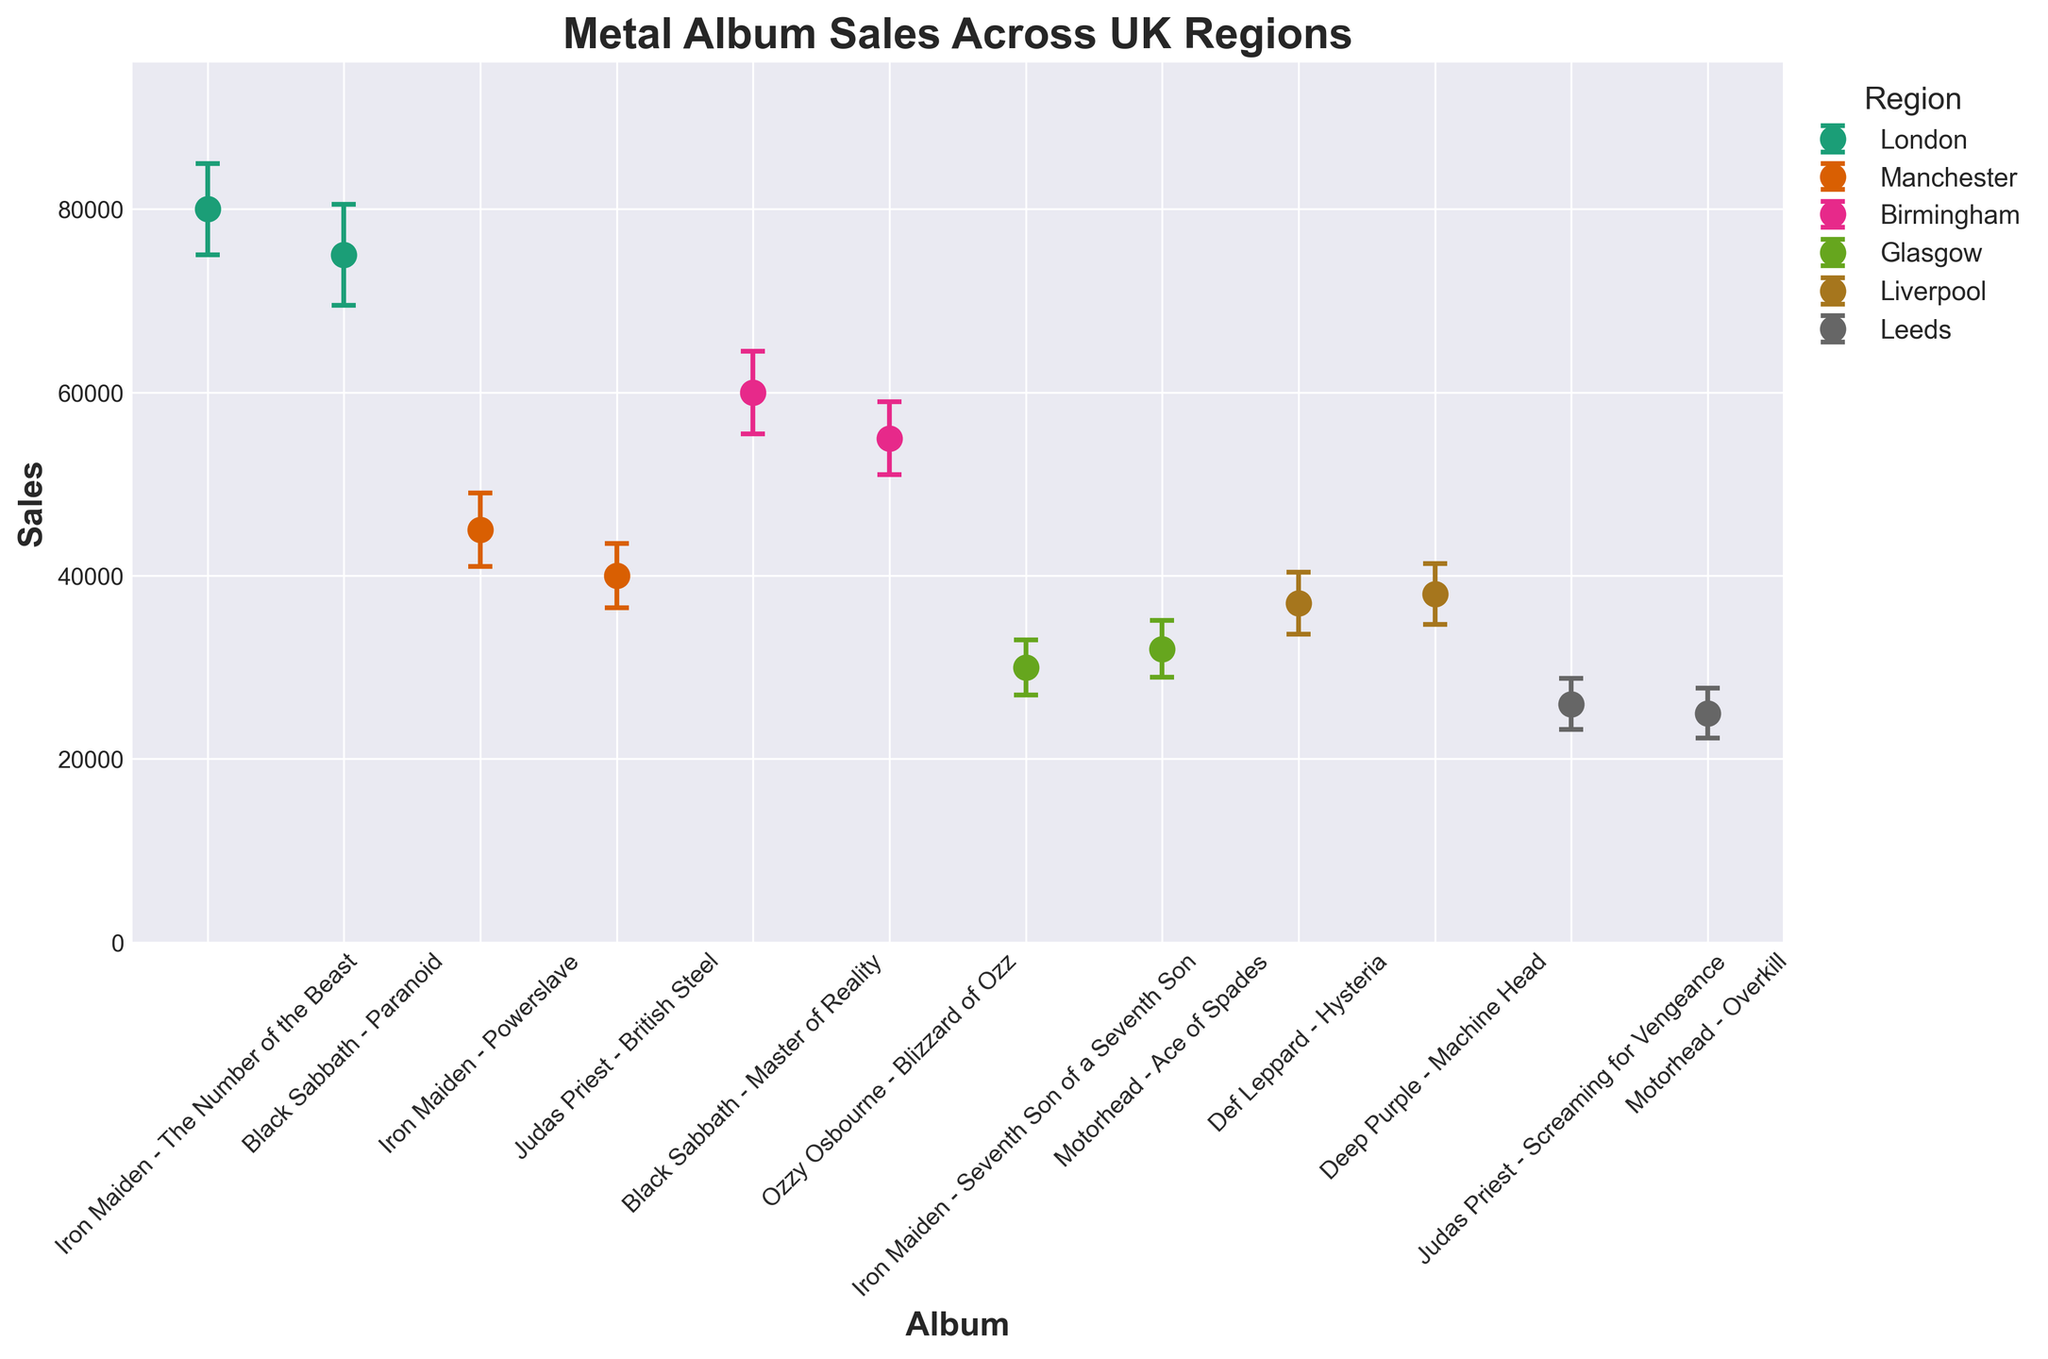What is the title of the figure? The title of the figure is text displayed prominently at the top of the plot. It's "Metal Album Sales Across UK Regions".
Answer: Metal Album Sales Across UK Regions Which region has the highest album sales for "The Number of the Beast"? The album "The Number of the Beast" by Iron Maiden is associated with London. By checking the sales values, London has the highest sales figure at 80,000.
Answer: London How many regions are represented in the plot? The regions are indicated by different colors in the legend on the right-hand side. There are 6 distinct regions: London, Manchester, Birmingham, Glasgow, Liverpool, and Leeds.
Answer: 6 What is the average album sales for Birmingham? Birmingham has two albums: "Master of Reality" with 60,000 sales and "Blizzard of Ozz" with 55,000 sales. The average is calculated as (60,000 + 55,000) / 2 = 57,500.
Answer: 57,500 Which album has the smallest error in sales reporting? The error bars represent the uncertainty in the sales figures. Among all albums, "Screaming for Vengeance" by Judas Priest (Leeds) has the smallest error at 2,800.
Answer: Screaming for Vengeance Which region has more sales: Manchester or Liverpool? Manchester has two albums with sales 45,000 and 40,000. Liverpool has two albums with sales 37,000 and 38,000. The totals are 85,000 for Manchester and 75,000 for Liverpool.
Answer: Manchester Which Iron Maiden album has the lowest sales? Iron Maiden has three albums listed. "The Number of the Beast" has 80,000, "Powerslave" has 45,000, and "Seventh Son of a Seventh Son" has 30,000. The lowest is 30,000 for "Seventh Son of a Seventh Son".
Answer: Seventh Son of a Seventh Son Which album has the highest sales overall and what region is it from? By visually comparing all bars, "The Number of the Beast" by Iron Maiden has the highest sales at 80,000. It is from the London region.
Answer: The Number of the Beast, London What is the combined sales total for all Metal albums from Glasgow? Glasgow has two albums, "Seventh Son of a Seventh Son" with 30,000 and "Ace of Spades" with 32,000 sales. The combined total is 30,000 + 32,000 = 62,000.
Answer: 62,000 Which region has the highest total sales amongst its albums listed? Summing the album sales for each region:
- London: 80,000 + 75,000 = 155,000
- Manchester: 45,000 + 40,000 = 85,000
- Birmingham: 60,000 + 55,000 = 115,000
- Glasgow: 30,000 + 32,000 = 62,000
- Liverpool: 37,000 + 38,000 = 75,000
- Leeds: 26,000 + 25,000 = 51,000
London has the highest total sales at 155,000.
Answer: London 